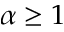<formula> <loc_0><loc_0><loc_500><loc_500>\alpha \geq 1</formula> 